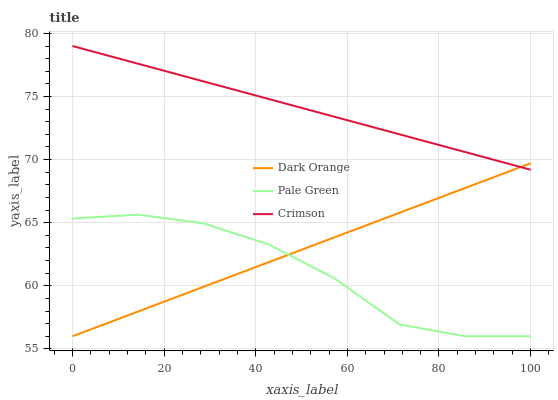Does Pale Green have the minimum area under the curve?
Answer yes or no. Yes. Does Crimson have the maximum area under the curve?
Answer yes or no. Yes. Does Dark Orange have the minimum area under the curve?
Answer yes or no. No. Does Dark Orange have the maximum area under the curve?
Answer yes or no. No. Is Dark Orange the smoothest?
Answer yes or no. Yes. Is Pale Green the roughest?
Answer yes or no. Yes. Is Pale Green the smoothest?
Answer yes or no. No. Is Dark Orange the roughest?
Answer yes or no. No. Does Dark Orange have the lowest value?
Answer yes or no. Yes. Does Crimson have the highest value?
Answer yes or no. Yes. Does Dark Orange have the highest value?
Answer yes or no. No. Is Pale Green less than Crimson?
Answer yes or no. Yes. Is Crimson greater than Pale Green?
Answer yes or no. Yes. Does Crimson intersect Dark Orange?
Answer yes or no. Yes. Is Crimson less than Dark Orange?
Answer yes or no. No. Is Crimson greater than Dark Orange?
Answer yes or no. No. Does Pale Green intersect Crimson?
Answer yes or no. No. 